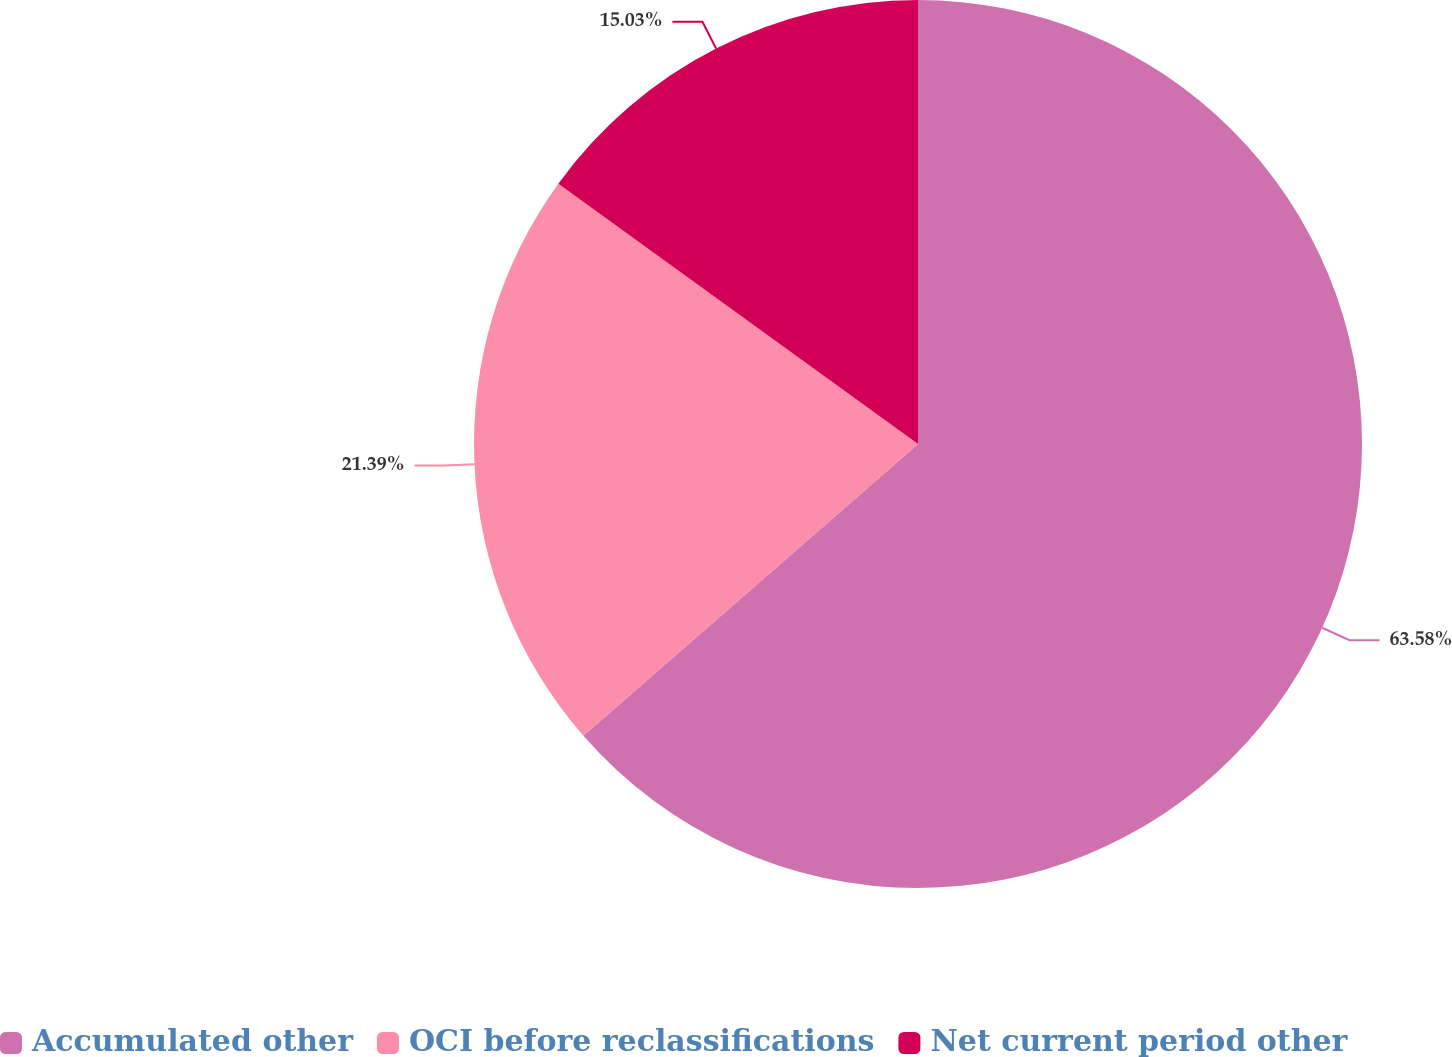Convert chart. <chart><loc_0><loc_0><loc_500><loc_500><pie_chart><fcel>Accumulated other<fcel>OCI before reclassifications<fcel>Net current period other<nl><fcel>63.59%<fcel>21.39%<fcel>15.03%<nl></chart> 